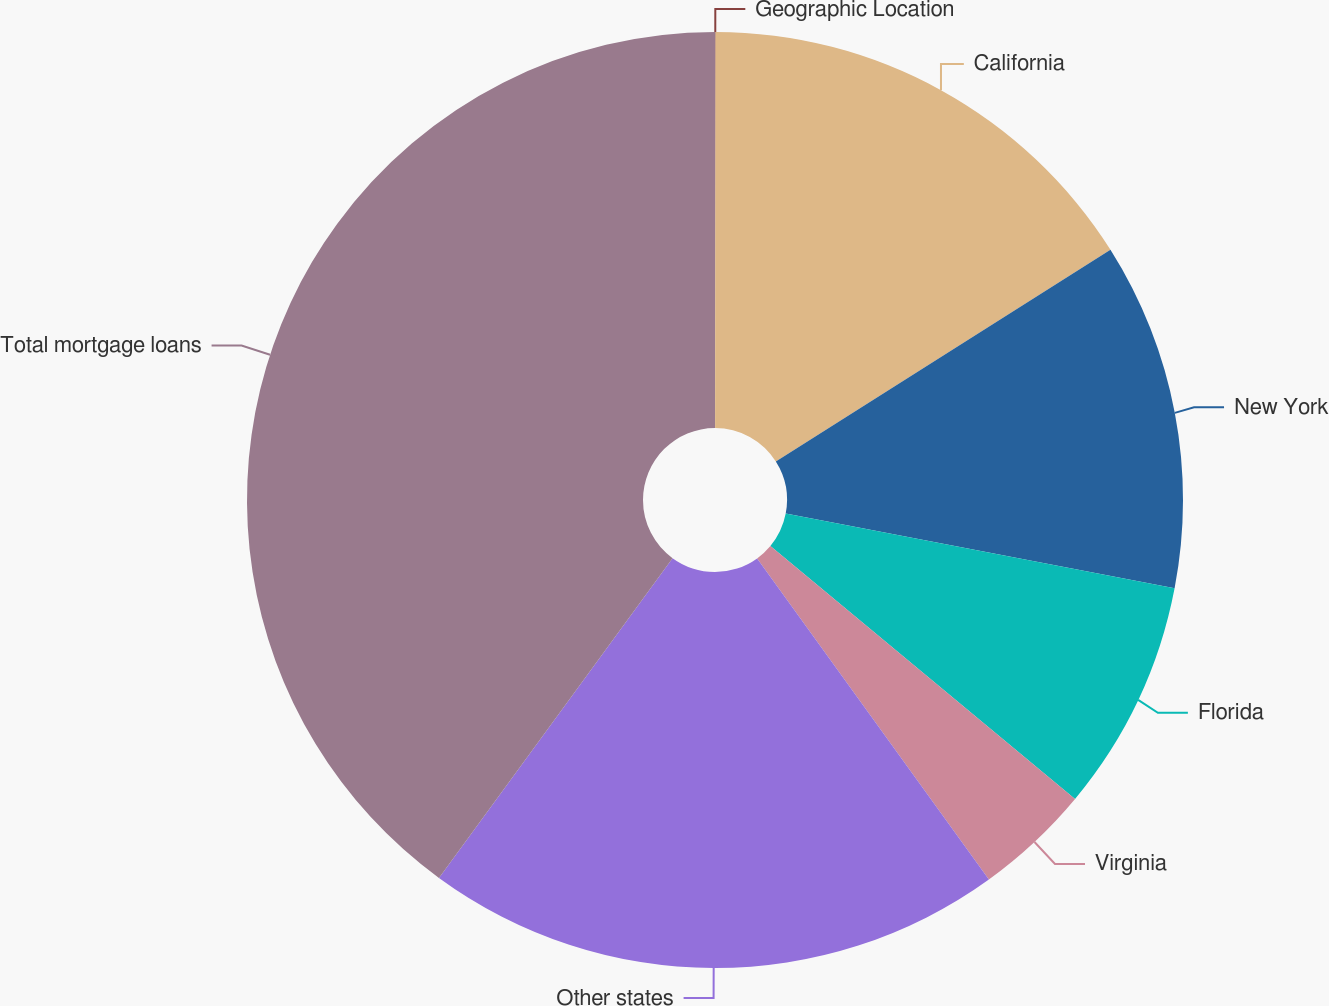<chart> <loc_0><loc_0><loc_500><loc_500><pie_chart><fcel>Geographic Location<fcel>California<fcel>New York<fcel>Florida<fcel>Virginia<fcel>Other states<fcel>Total mortgage loans<nl><fcel>0.02%<fcel>16.0%<fcel>12.0%<fcel>8.01%<fcel>4.02%<fcel>19.99%<fcel>39.96%<nl></chart> 